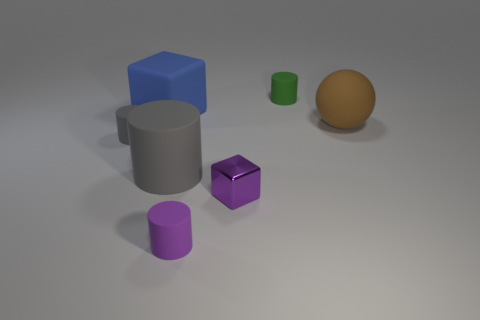Subtract 1 cylinders. How many cylinders are left? 3 Subtract all blue cylinders. Subtract all yellow spheres. How many cylinders are left? 4 Add 2 small blue metallic cylinders. How many objects exist? 9 Subtract all blocks. How many objects are left? 5 Subtract 1 gray cylinders. How many objects are left? 6 Subtract all green cylinders. Subtract all small rubber objects. How many objects are left? 3 Add 1 tiny green things. How many tiny green things are left? 2 Add 6 metallic objects. How many metallic objects exist? 7 